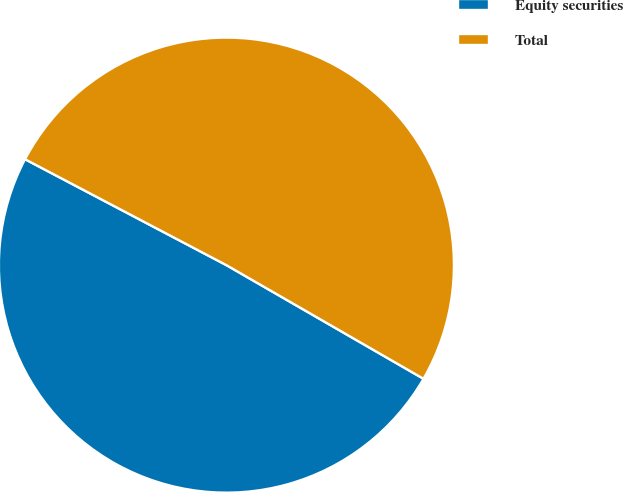<chart> <loc_0><loc_0><loc_500><loc_500><pie_chart><fcel>Equity securities<fcel>Total<nl><fcel>49.38%<fcel>50.62%<nl></chart> 